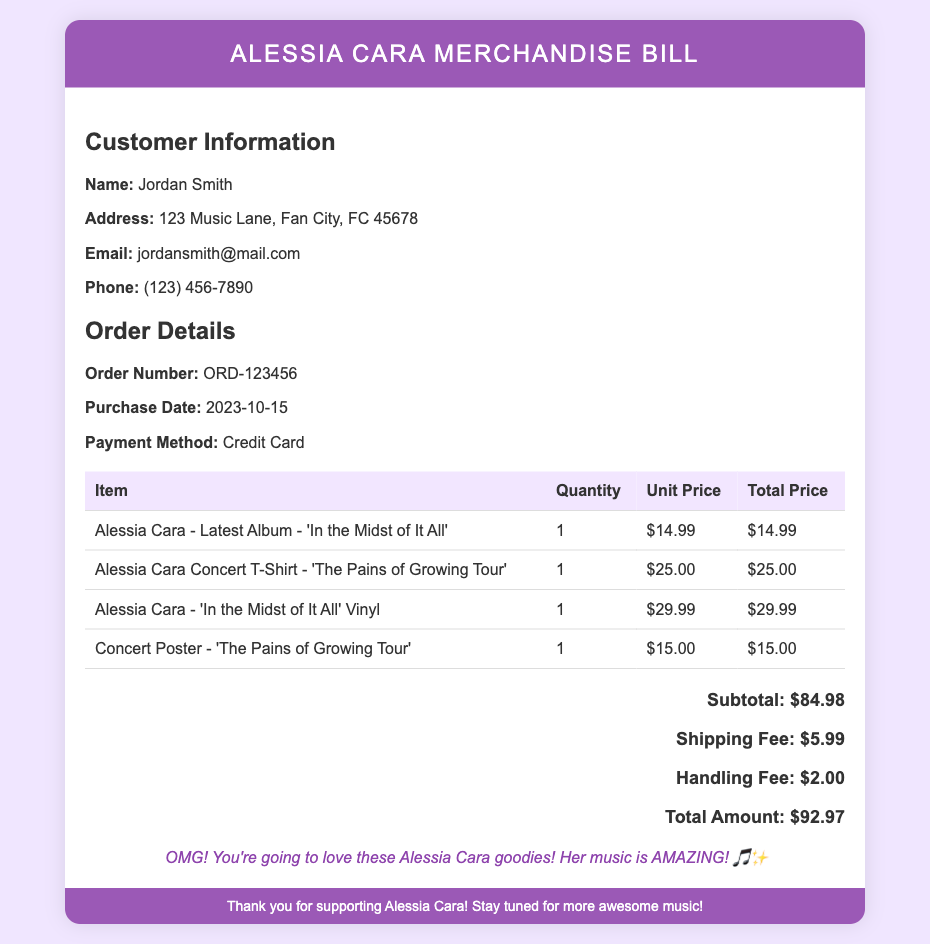What is the customer’s name? The document provides detailed customer information, including the name section.
Answer: Jordan Smith What is the order number? The order details section includes the unique order number for tracking.
Answer: ORD-123456 What was the purchase date? The purchase date can be found in the order details of the document.
Answer: 2023-10-15 How much is the shipping fee? The document clearly lists the shipping fee in the total cost section.
Answer: $5.99 What is the total amount due? The total amount due is calculated at the end of the bill and is listed for payment.
Answer: $92.97 How many items did Jordan purchase? By adding the quantities of each item listed in the order details, you can determine the total number of items.
Answer: 4 What type of payment was used? The payment method is specifically mentioned in the order details section.
Answer: Credit Card What is the unit price of the Vinyl? The table provides the unit price for each listed item, including the Vinyl.
Answer: $29.99 What is the title of Alessia Cara's latest album? The album title is mentioned in the item description of the merchandise.
Answer: In the Midst of It All 